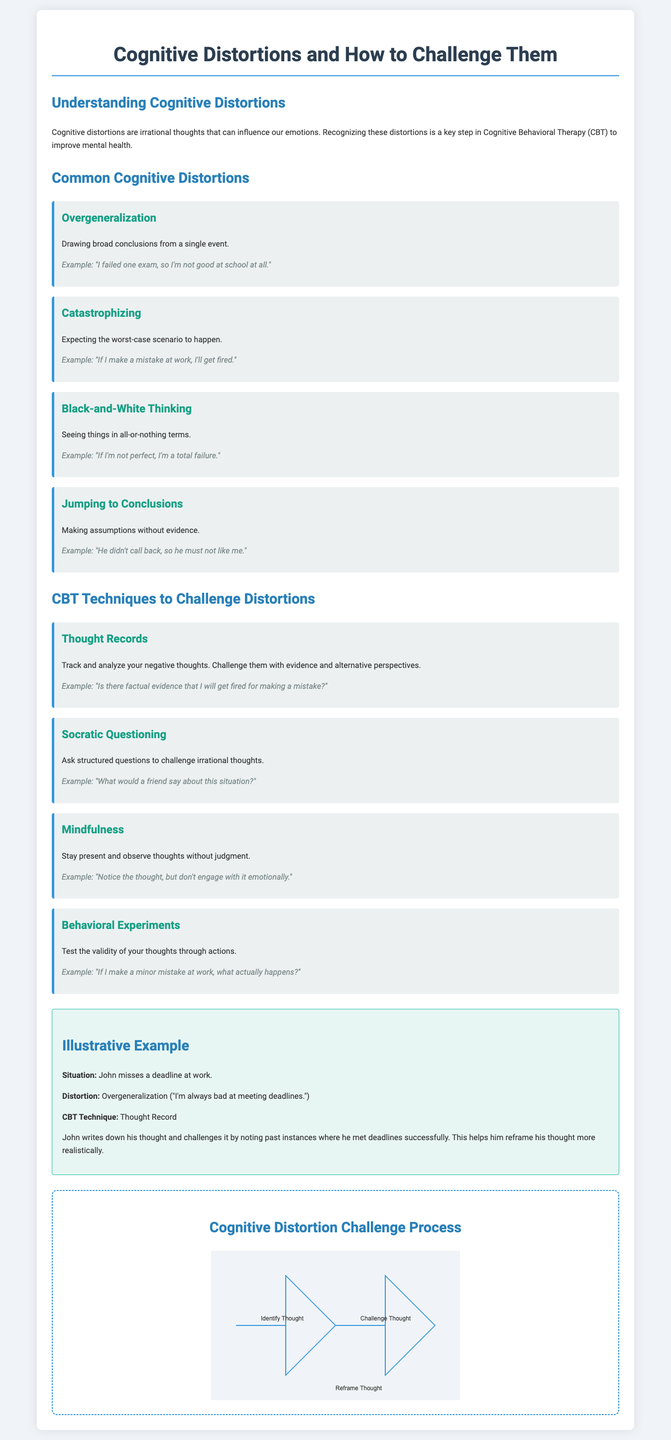What are cognitive distortions? Cognitive distortions are irrational thoughts that can influence our emotions.
Answer: Irrational thoughts Who is the author of the illustrated example? The document gives an example using a character named John.
Answer: John What cognitive distortion is associated with the thought "If I'm not perfect, I'm a total failure"? This thought pattern is identified as Black-and-White Thinking.
Answer: Black-and-White Thinking Which CBT technique is used to track and analyze negative thoughts? The document specifies Thought Records as a technique for this purpose.
Answer: Thought Records What is the color of the background in the cognitive distortion challenge process diagram? The diagram's background color is light blue (#f0f4f8).
Answer: Light blue What does the CBT technique "Mindfulness" emphasize? Mindfulness emphasizes staying present and observing thoughts without judgment.
Answer: Present observation How many common cognitive distortions are outlined in the document? The document outlines four common cognitive distortions.
Answer: Four What is the last step in the Cognitive Distortion Challenge Process? The last step in the process is to "Reframe Thought."
Answer: Reframe Thought What does the example of John's situation illustrate? It illustrates the cognitive distortion of Overgeneralization.
Answer: Overgeneralization 